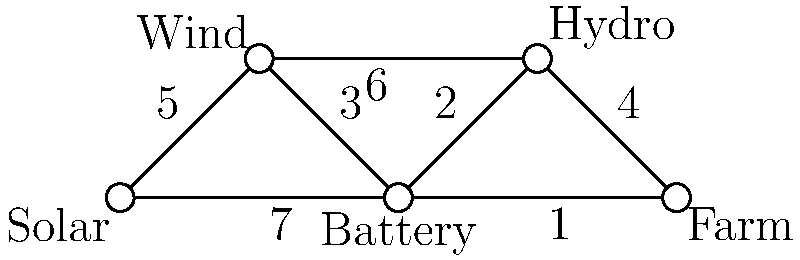Given the graph representing an off-grid power distribution network for a small farm, where vertices represent power sources and the farm, and edge weights represent energy loss during transmission (lower is better), what is the minimum spanning tree that connects all power sources to the farm with the least total energy loss? To find the minimum spanning tree (MST) that connects all power sources to the farm with the least total energy loss, we can use Kruskal's algorithm:

1. Sort all edges by weight in ascending order:
   (Battery - Farm): 1
   (Battery - Hydro): 2
   (Wind - Battery): 3
   (Hydro - Farm): 4
   (Solar - Wind): 5
   (Wind - Hydro): 6
   (Solar - Battery): 7

2. Start with an empty MST and add edges in order, skipping those that would create a cycle:
   a. Add (Battery - Farm): 1
   b. Add (Battery - Hydro): 2
   c. Add (Wind - Battery): 3
   d. Add (Solar - Wind): 5

3. The MST is complete as it now includes all vertices.

The resulting MST consists of the edges:
1. Battery - Farm (1)
2. Battery - Hydro (2)
3. Wind - Battery (3)
4. Solar - Wind (5)

The total energy loss in this configuration is $1 + 2 + 3 + 5 = 11$.
Answer: Solar-Wind-Battery-Hydro-Farm, total energy loss: 11 